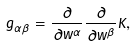<formula> <loc_0><loc_0><loc_500><loc_500>g _ { \alpha \bar { \beta } } = { \frac { \partial } { \partial w ^ { \alpha } } } { \frac { \partial } { \partial \bar { w } ^ { \beta } } } K ,</formula> 